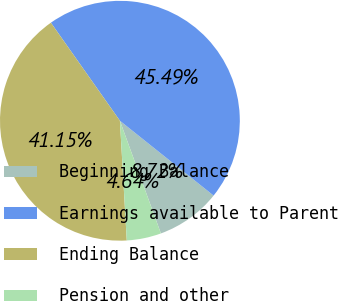Convert chart to OTSL. <chart><loc_0><loc_0><loc_500><loc_500><pie_chart><fcel>Beginning Balance<fcel>Earnings available to Parent<fcel>Ending Balance<fcel>Pension and other<nl><fcel>8.72%<fcel>45.49%<fcel>41.15%<fcel>4.64%<nl></chart> 